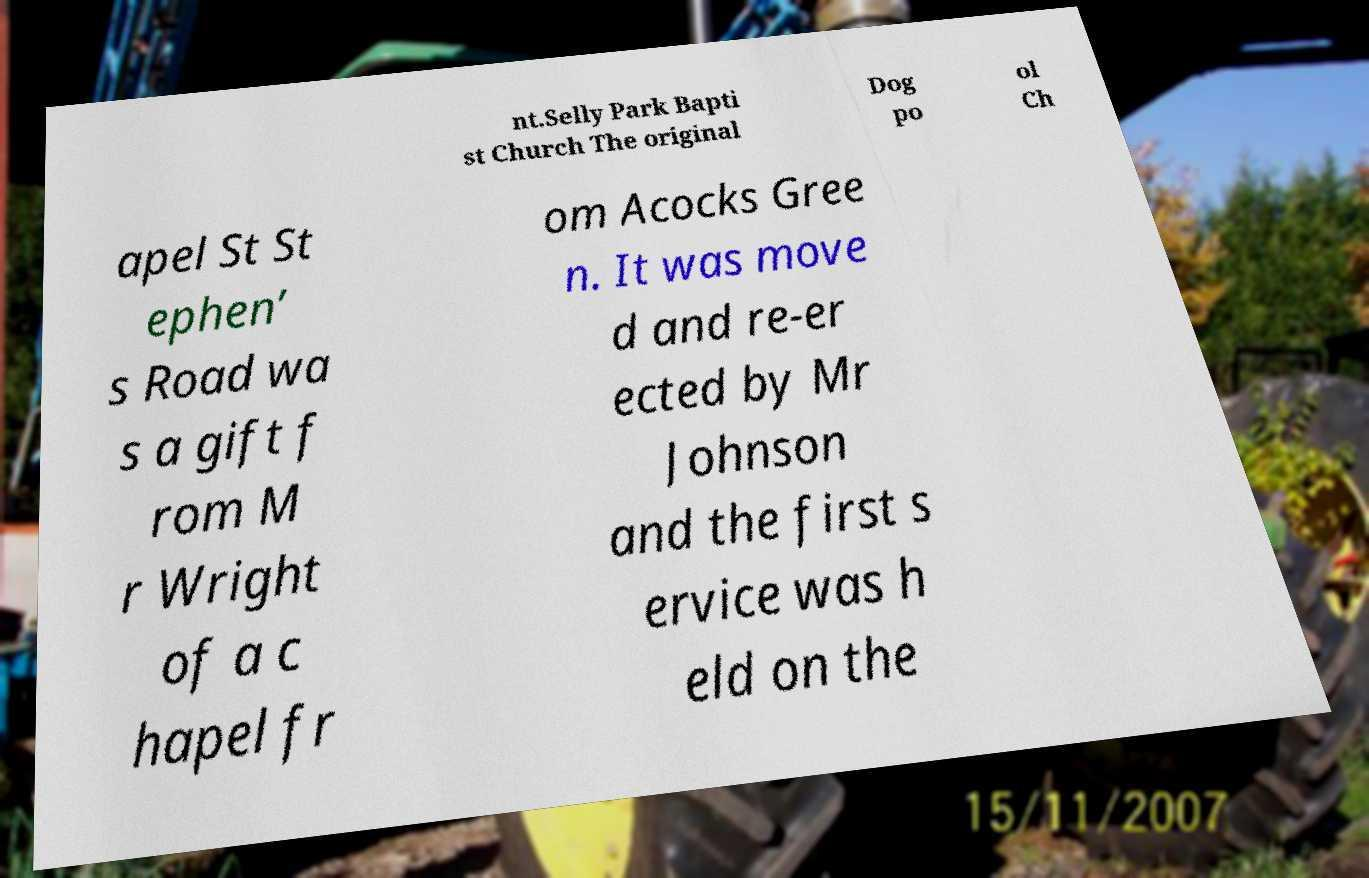I need the written content from this picture converted into text. Can you do that? nt.Selly Park Bapti st Church The original Dog po ol Ch apel St St ephen’ s Road wa s a gift f rom M r Wright of a c hapel fr om Acocks Gree n. It was move d and re-er ected by Mr Johnson and the first s ervice was h eld on the 